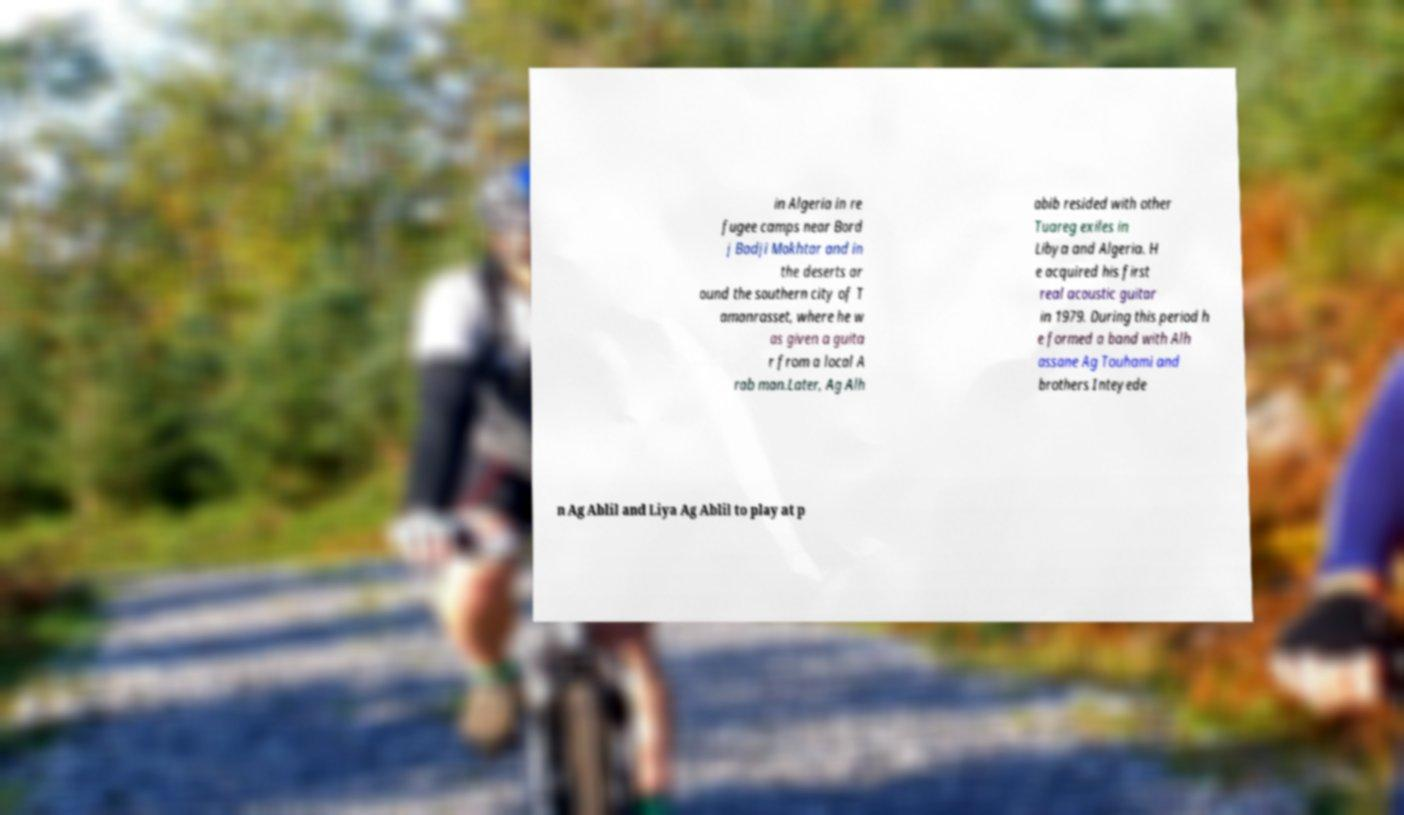Could you extract and type out the text from this image? in Algeria in re fugee camps near Bord j Badji Mokhtar and in the deserts ar ound the southern city of T amanrasset, where he w as given a guita r from a local A rab man.Later, Ag Alh abib resided with other Tuareg exiles in Libya and Algeria. H e acquired his first real acoustic guitar in 1979. During this period h e formed a band with Alh assane Ag Touhami and brothers Inteyede n Ag Ablil and Liya Ag Ablil to play at p 